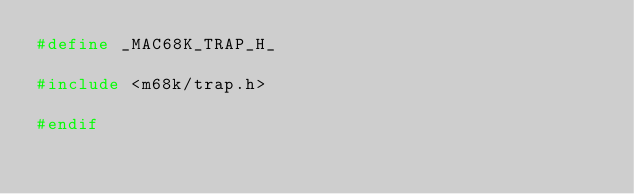Convert code to text. <code><loc_0><loc_0><loc_500><loc_500><_C_>#define _MAC68K_TRAP_H_

#include <m68k/trap.h>

#endif
</code> 